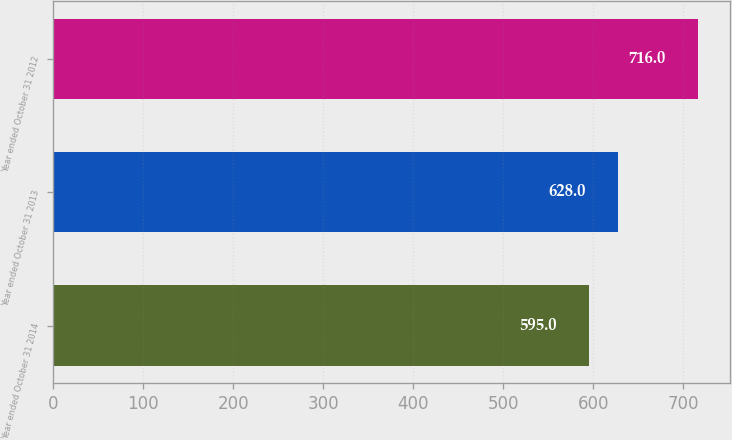Convert chart. <chart><loc_0><loc_0><loc_500><loc_500><bar_chart><fcel>Year ended October 31 2014<fcel>Year ended October 31 2013<fcel>Year ended October 31 2012<nl><fcel>595<fcel>628<fcel>716<nl></chart> 